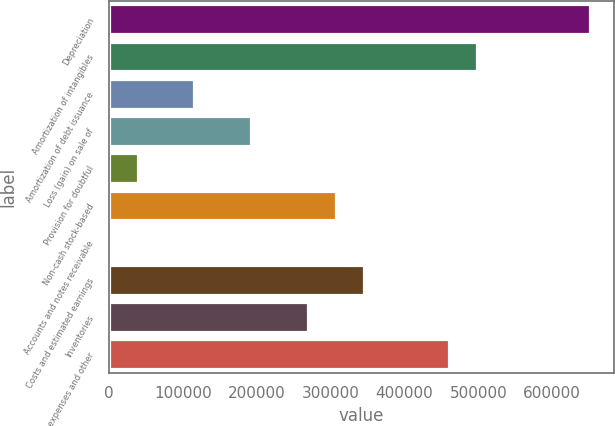<chart> <loc_0><loc_0><loc_500><loc_500><bar_chart><fcel>Depreciation<fcel>Amortization of intangibles<fcel>Amortization of debt issuance<fcel>Loss (gain) on sale of<fcel>Provision for doubtful<fcel>Non-cash stock-based<fcel>Accounts and notes receivable<fcel>Costs and estimated earnings<fcel>Inventories<fcel>Prepaid expenses and other<nl><fcel>651542<fcel>498482<fcel>115832<fcel>192362<fcel>39302<fcel>307157<fcel>1037<fcel>345422<fcel>268892<fcel>460217<nl></chart> 